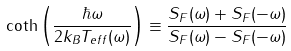Convert formula to latex. <formula><loc_0><loc_0><loc_500><loc_500>\coth \left ( \frac { \hbar { \omega } } { 2 k _ { B } T _ { e f f } ( \omega ) } \right ) \equiv \frac { S _ { F } ( \omega ) + S _ { F } ( - \omega ) } { S _ { F } ( \omega ) - S _ { F } ( - \omega ) }</formula> 